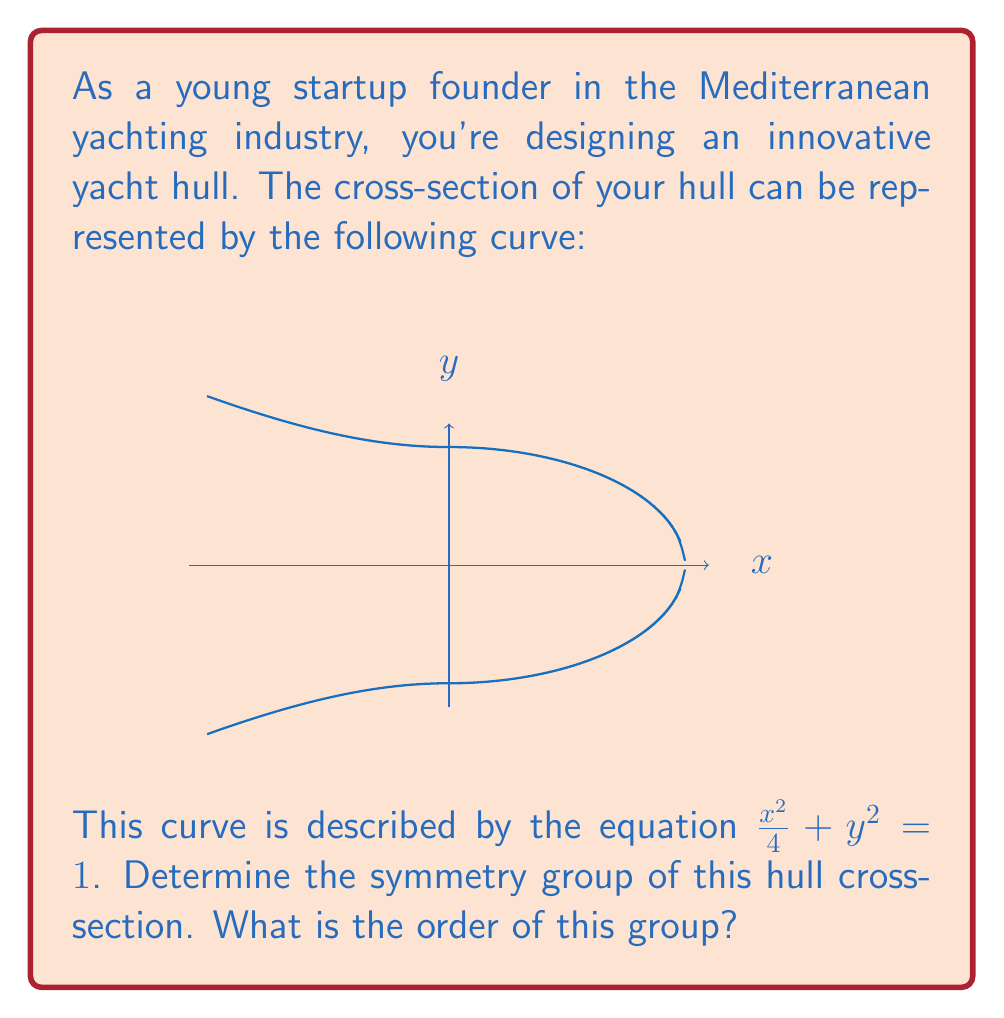Provide a solution to this math problem. Let's approach this step-by-step:

1) First, we need to identify all the symmetries of this shape. Looking at the curve, we can see that it has:
   - Reflection symmetry about the y-axis
   - Reflection symmetry about the x-axis
   - 180° rotational symmetry about the origin
   - Identity transformation (leaving it unchanged)

2) These symmetries form a group. Let's denote them as:
   - $I$: Identity
   - $R_{x}$: Reflection about x-axis
   - $R_{y}$: Reflection about y-axis
   - $R_{180}$: 180° rotation

3) We can verify that these form a group:
   - The set is closed under composition
   - The identity element $I$ exists
   - Each element has an inverse
   - The operation (composition of transformations) is associative

4) This group is isomorphic to the Klein four-group, $V_4$ or $C_2 \times C_2$

5) To find the order of the group, we simply count the number of elements: 4

Therefore, the symmetry group of this hull cross-section is the Klein four-group, which has an order of 4.
Answer: Klein four-group, order 4 